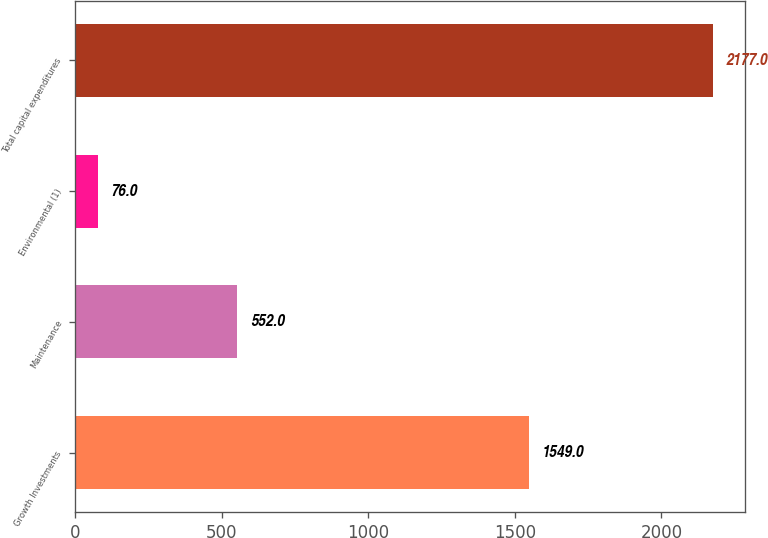Convert chart. <chart><loc_0><loc_0><loc_500><loc_500><bar_chart><fcel>Growth Investments<fcel>Maintenance<fcel>Environmental (1)<fcel>Total capital expenditures<nl><fcel>1549<fcel>552<fcel>76<fcel>2177<nl></chart> 